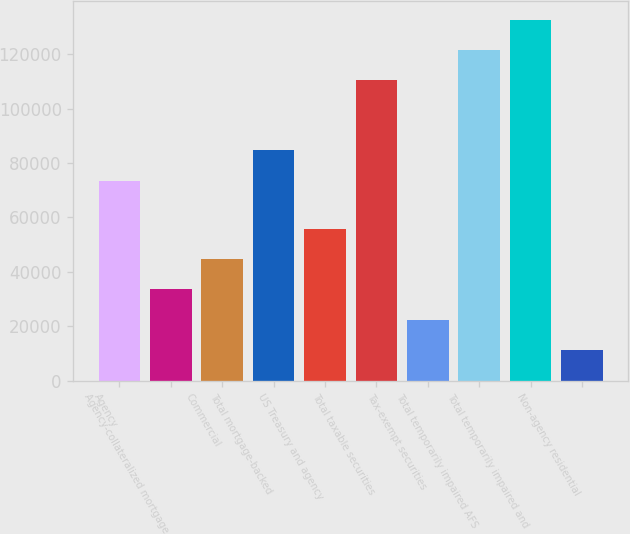<chart> <loc_0><loc_0><loc_500><loc_500><bar_chart><fcel>Agency<fcel>Agency-collateralized mortgage<fcel>Commercial<fcel>Total mortgage-backed<fcel>US Treasury and agency<fcel>Total taxable securities<fcel>Tax-exempt securities<fcel>Total temporarily impaired AFS<fcel>Total temporarily impaired and<fcel>Non-agency residential<nl><fcel>73535<fcel>33559.3<fcel>44714.4<fcel>84690.1<fcel>55869.5<fcel>110497<fcel>22404.2<fcel>121652<fcel>132807<fcel>11249.1<nl></chart> 